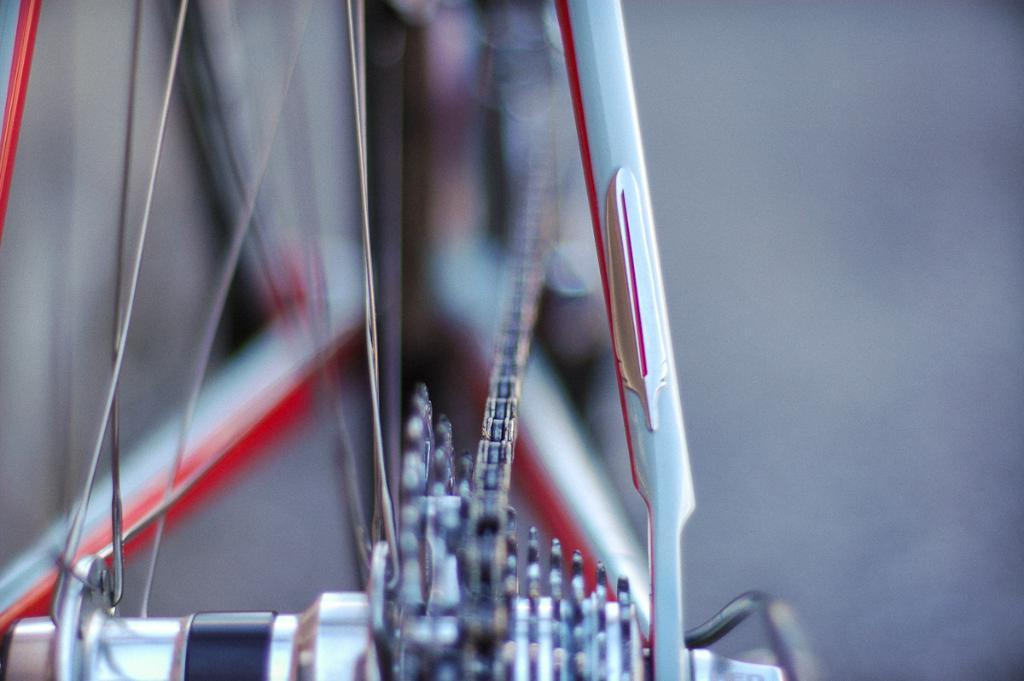What is the main object in the image? There is a cycle wheel in the image. What is attached to the cycle wheel? There is a chain in the image. Can you describe the background of the image? The background of the image is blurred. What type of engine can be seen powering the cycle in the image? There is no engine present in the image; it only features a cycle wheel and a chain. 